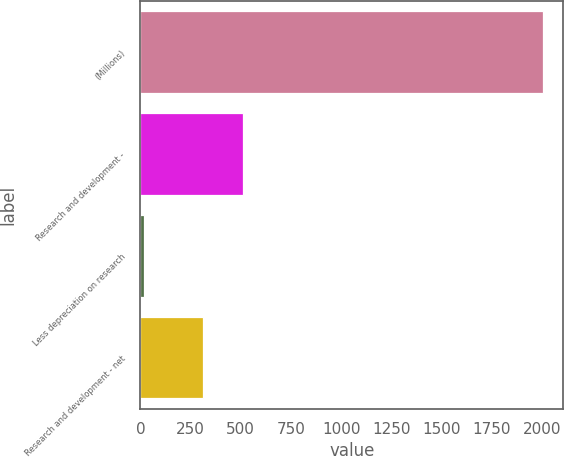Convert chart. <chart><loc_0><loc_0><loc_500><loc_500><bar_chart><fcel>(Millions)<fcel>Research and development -<fcel>Less depreciation on research<fcel>Research and development - net<nl><fcel>2006<fcel>513<fcel>16<fcel>314<nl></chart> 